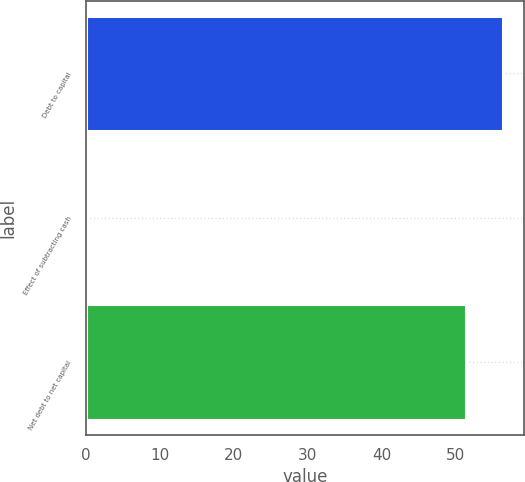Convert chart to OTSL. <chart><loc_0><loc_0><loc_500><loc_500><bar_chart><fcel>Debt to capital<fcel>Effect of subtracting cash<fcel>Net debt to net capital<nl><fcel>56.43<fcel>0.2<fcel>51.3<nl></chart> 